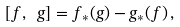<formula> <loc_0><loc_0><loc_500><loc_500>[ f , \ g ] = f _ { * } ( g ) - g _ { * } ( f ) \, ,</formula> 